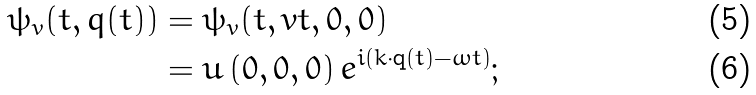Convert formula to latex. <formula><loc_0><loc_0><loc_500><loc_500>\psi _ { v } ( t , q ( t ) ) & = \psi _ { v } ( t , v t , 0 , 0 ) \\ & = u \left ( 0 , 0 , 0 \right ) e ^ { i ( k \cdot \mathbf { q } ( t ) - \omega t ) } ;</formula> 